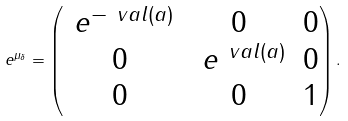Convert formula to latex. <formula><loc_0><loc_0><loc_500><loc_500>\ e ^ { \mu _ { \delta } } = \begin{pmatrix} \ e ^ { - \ v a l ( a ) } & 0 & 0 \\ 0 & \ e ^ { \ v a l ( a ) } & 0 \\ 0 & 0 & 1 \end{pmatrix} .</formula> 